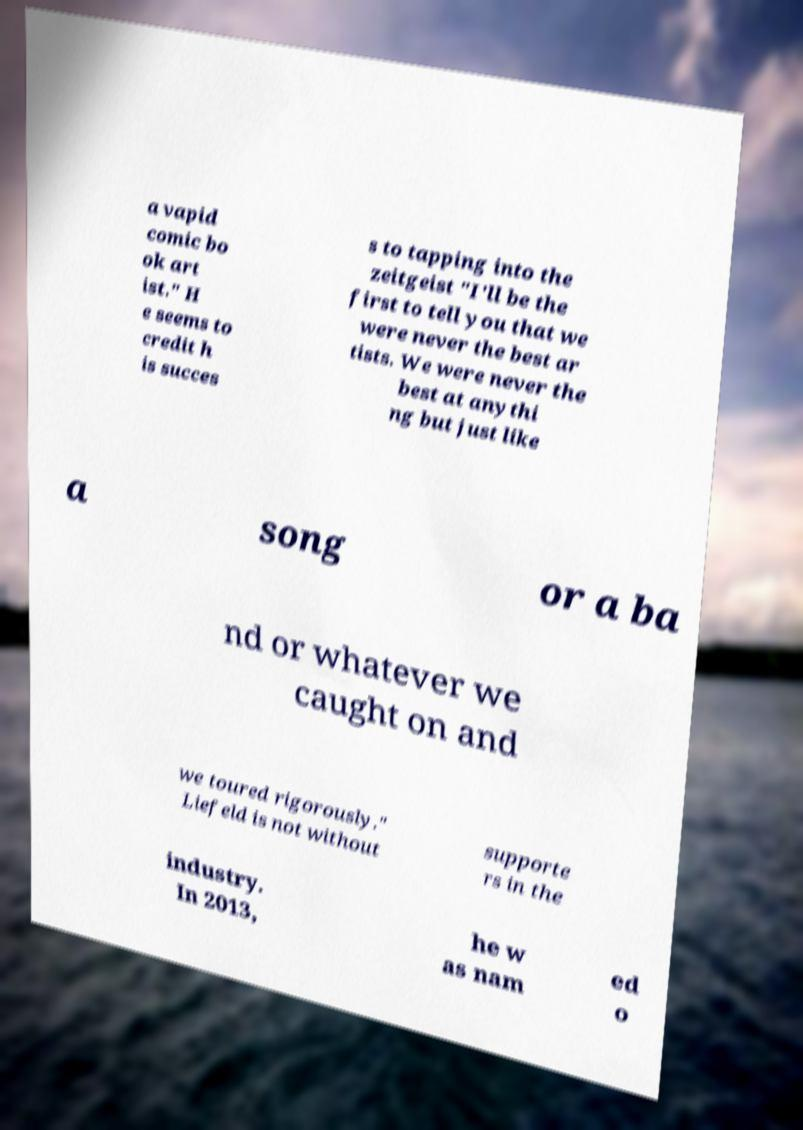Can you accurately transcribe the text from the provided image for me? a vapid comic bo ok art ist." H e seems to credit h is succes s to tapping into the zeitgeist "I'll be the first to tell you that we were never the best ar tists. We were never the best at anythi ng but just like a song or a ba nd or whatever we caught on and we toured rigorously." Liefeld is not without supporte rs in the industry. In 2013, he w as nam ed o 